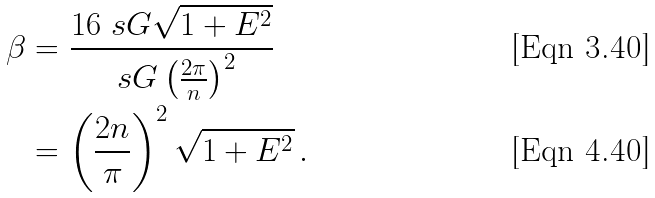Convert formula to latex. <formula><loc_0><loc_0><loc_500><loc_500>\beta & = \frac { 1 6 \ s G \sqrt { 1 + E ^ { 2 } } } { \ s G \left ( \frac { 2 \pi } { n } \right ) ^ { 2 } } \\ & = \left ( \frac { 2 n } { \pi } \right ) ^ { 2 } \sqrt { 1 + E ^ { 2 } } \, .</formula> 